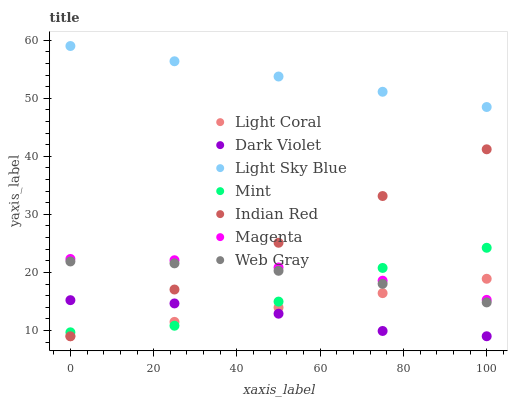Does Dark Violet have the minimum area under the curve?
Answer yes or no. Yes. Does Light Sky Blue have the maximum area under the curve?
Answer yes or no. Yes. Does Light Coral have the minimum area under the curve?
Answer yes or no. No. Does Light Coral have the maximum area under the curve?
Answer yes or no. No. Is Light Coral the smoothest?
Answer yes or no. Yes. Is Mint the roughest?
Answer yes or no. Yes. Is Dark Violet the smoothest?
Answer yes or no. No. Is Dark Violet the roughest?
Answer yes or no. No. Does Dark Violet have the lowest value?
Answer yes or no. Yes. Does Light Sky Blue have the lowest value?
Answer yes or no. No. Does Light Sky Blue have the highest value?
Answer yes or no. Yes. Does Light Coral have the highest value?
Answer yes or no. No. Is Mint less than Light Sky Blue?
Answer yes or no. Yes. Is Light Sky Blue greater than Mint?
Answer yes or no. Yes. Does Magenta intersect Light Coral?
Answer yes or no. Yes. Is Magenta less than Light Coral?
Answer yes or no. No. Is Magenta greater than Light Coral?
Answer yes or no. No. Does Mint intersect Light Sky Blue?
Answer yes or no. No. 